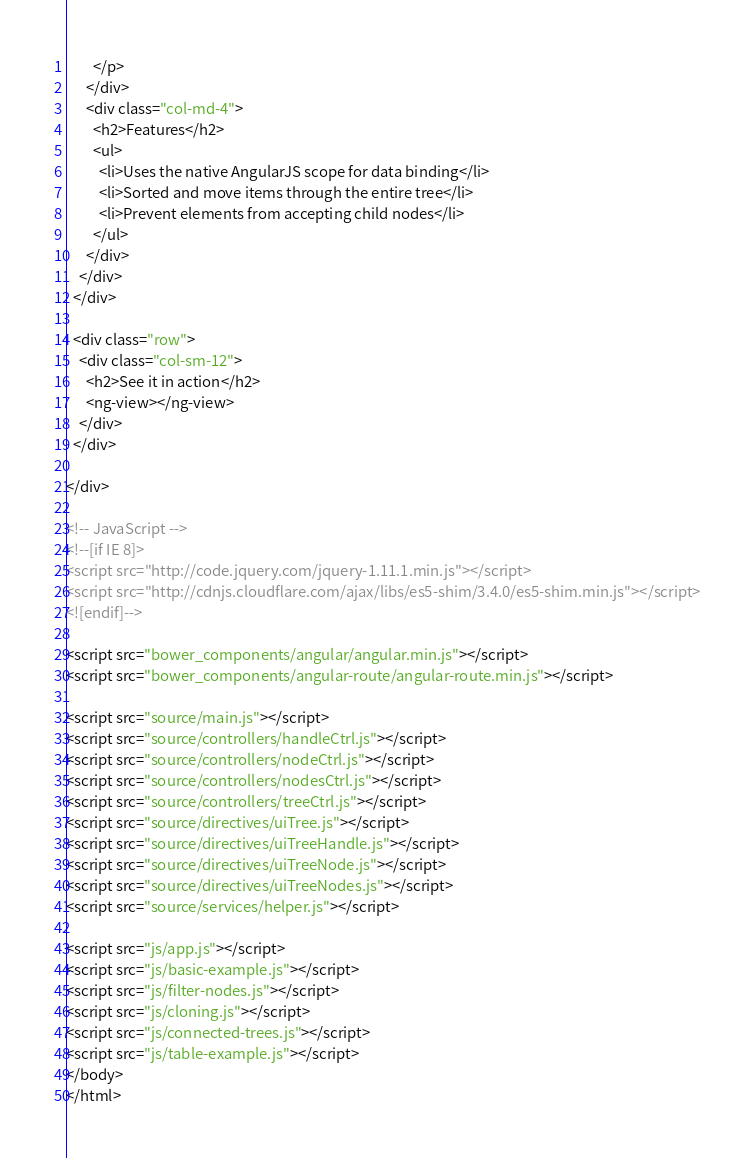<code> <loc_0><loc_0><loc_500><loc_500><_HTML_>        </p>
      </div>
      <div class="col-md-4">
        <h2>Features</h2>
        <ul>
          <li>Uses the native AngularJS scope for data binding</li>
          <li>Sorted and move items through the entire tree</li>
          <li>Prevent elements from accepting child nodes</li>
        </ul>
      </div>
    </div>
  </div>

  <div class="row">
    <div class="col-sm-12">
      <h2>See it in action</h2>
      <ng-view></ng-view>
    </div>
  </div>

</div>

<!-- JavaScript -->
<!--[if IE 8]>
<script src="http://code.jquery.com/jquery-1.11.1.min.js"></script>
<script src="http://cdnjs.cloudflare.com/ajax/libs/es5-shim/3.4.0/es5-shim.min.js"></script>
<![endif]-->

<script src="bower_components/angular/angular.min.js"></script>
<script src="bower_components/angular-route/angular-route.min.js"></script>

<script src="source/main.js"></script>
<script src="source/controllers/handleCtrl.js"></script>
<script src="source/controllers/nodeCtrl.js"></script>
<script src="source/controllers/nodesCtrl.js"></script>
<script src="source/controllers/treeCtrl.js"></script>
<script src="source/directives/uiTree.js"></script>
<script src="source/directives/uiTreeHandle.js"></script>
<script src="source/directives/uiTreeNode.js"></script>
<script src="source/directives/uiTreeNodes.js"></script>
<script src="source/services/helper.js"></script>

<script src="js/app.js"></script>
<script src="js/basic-example.js"></script>
<script src="js/filter-nodes.js"></script>
<script src="js/cloning.js"></script>
<script src="js/connected-trees.js"></script>
<script src="js/table-example.js"></script>
</body>
</html>
</code> 